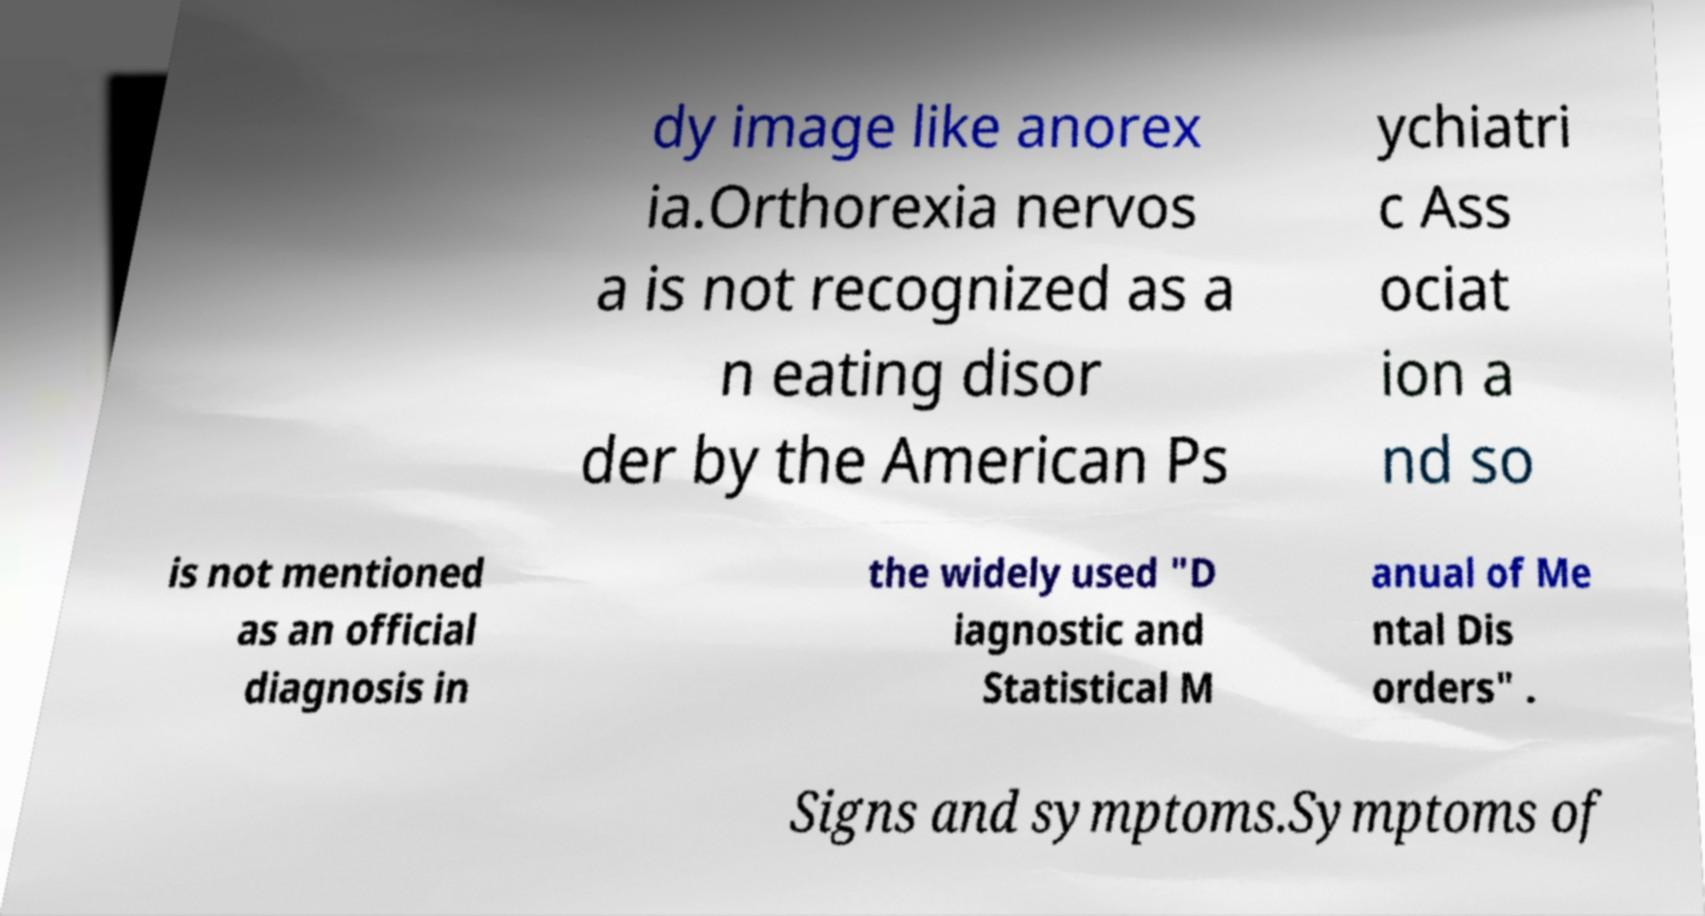Could you assist in decoding the text presented in this image and type it out clearly? dy image like anorex ia.Orthorexia nervos a is not recognized as a n eating disor der by the American Ps ychiatri c Ass ociat ion a nd so is not mentioned as an official diagnosis in the widely used "D iagnostic and Statistical M anual of Me ntal Dis orders" . Signs and symptoms.Symptoms of 